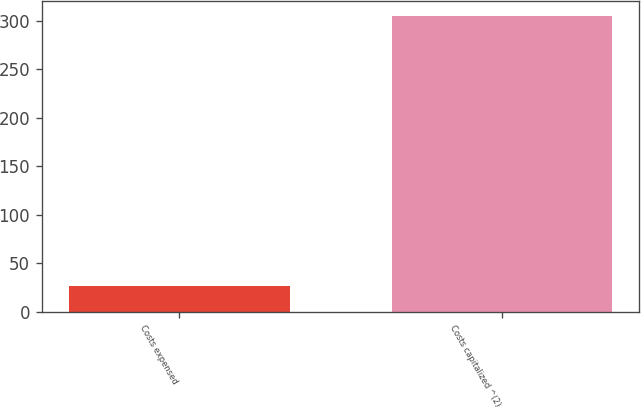Convert chart to OTSL. <chart><loc_0><loc_0><loc_500><loc_500><bar_chart><fcel>Costs expensed<fcel>Costs capitalized ^(2)<nl><fcel>26<fcel>305<nl></chart> 